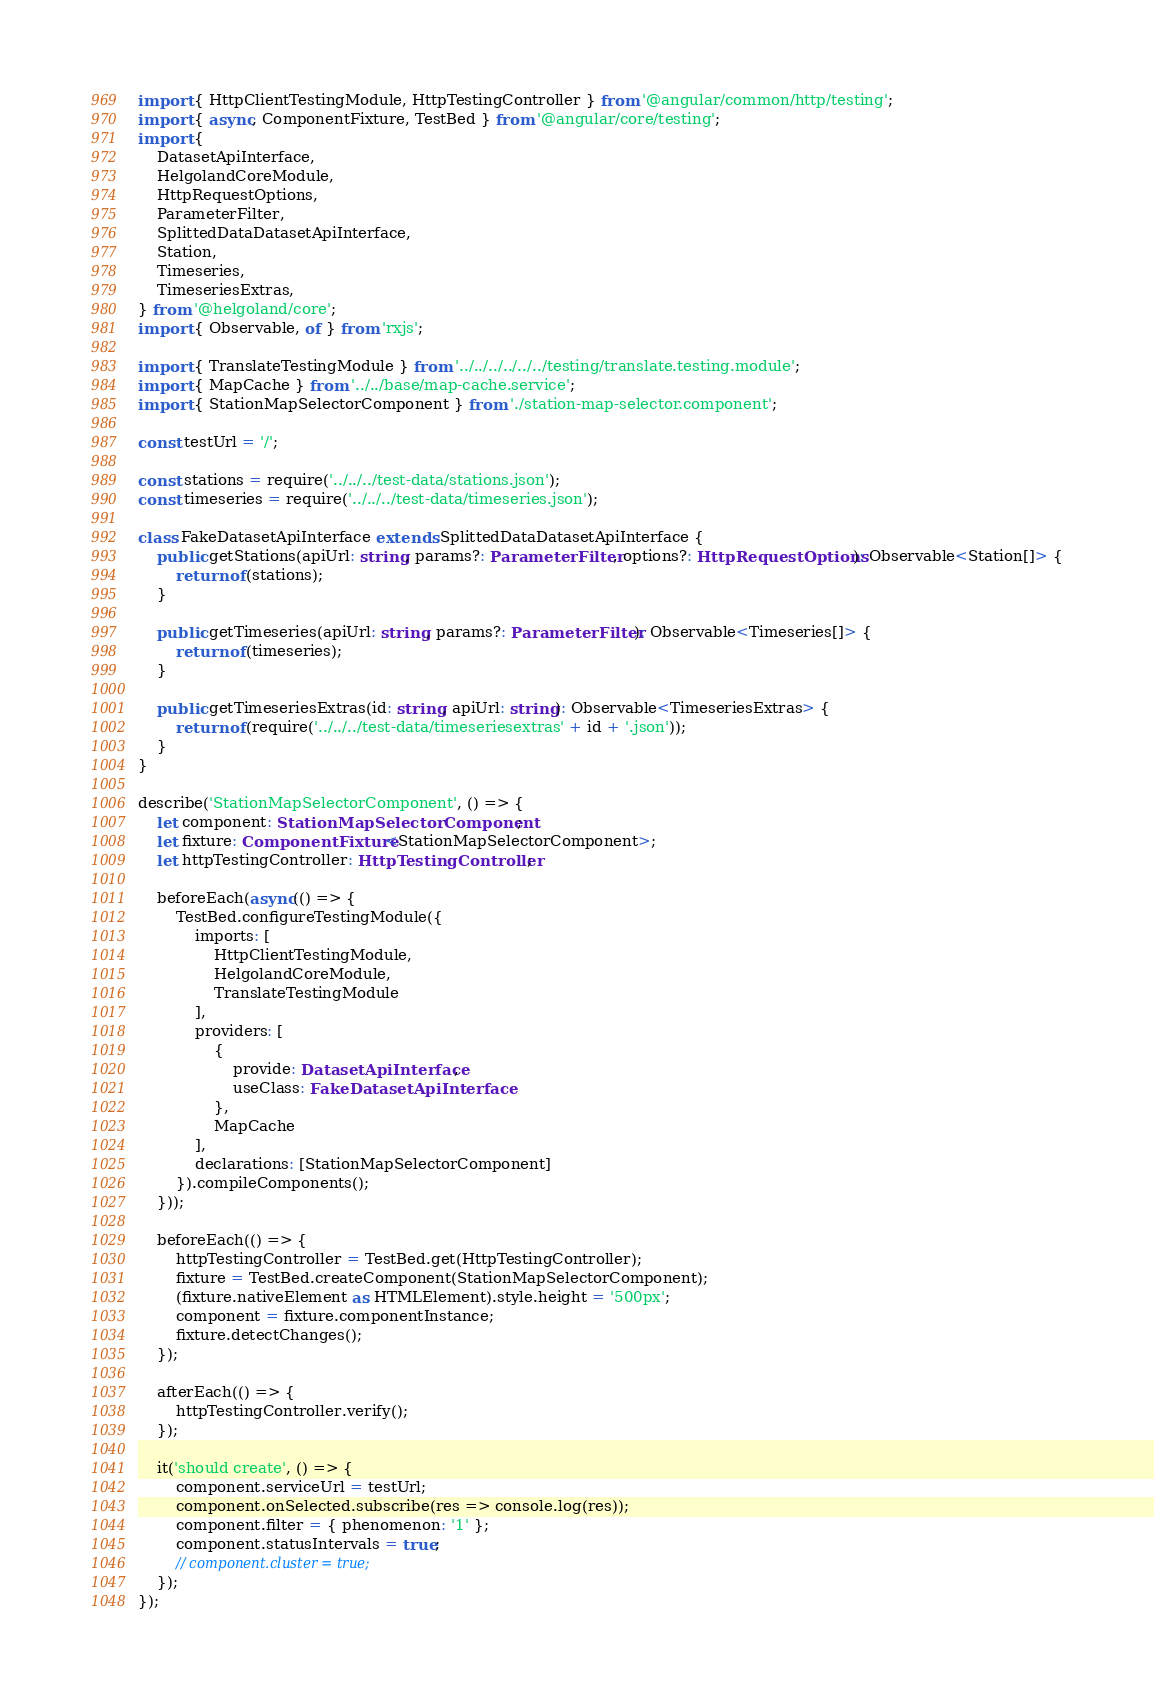<code> <loc_0><loc_0><loc_500><loc_500><_TypeScript_>import { HttpClientTestingModule, HttpTestingController } from '@angular/common/http/testing';
import { async, ComponentFixture, TestBed } from '@angular/core/testing';
import {
    DatasetApiInterface,
    HelgolandCoreModule,
    HttpRequestOptions,
    ParameterFilter,
    SplittedDataDatasetApiInterface,
    Station,
    Timeseries,
    TimeseriesExtras,
} from '@helgoland/core';
import { Observable, of } from 'rxjs';

import { TranslateTestingModule } from '../../../../../../testing/translate.testing.module';
import { MapCache } from '../../base/map-cache.service';
import { StationMapSelectorComponent } from './station-map-selector.component';

const testUrl = '/';

const stations = require('../../../test-data/stations.json');
const timeseries = require('../../../test-data/timeseries.json');

class FakeDatasetApiInterface extends SplittedDataDatasetApiInterface {
    public getStations(apiUrl: string, params?: ParameterFilter, options?: HttpRequestOptions): Observable<Station[]> {
        return of(stations);
    }

    public getTimeseries(apiUrl: string, params?: ParameterFilter): Observable<Timeseries[]> {
        return of(timeseries);
    }

    public getTimeseriesExtras(id: string, apiUrl: string): Observable<TimeseriesExtras> {
        return of(require('../../../test-data/timeseriesextras' + id + '.json'));
    }
}

describe('StationMapSelectorComponent', () => {
    let component: StationMapSelectorComponent;
    let fixture: ComponentFixture<StationMapSelectorComponent>;
    let httpTestingController: HttpTestingController;

    beforeEach(async(() => {
        TestBed.configureTestingModule({
            imports: [
                HttpClientTestingModule,
                HelgolandCoreModule,
                TranslateTestingModule
            ],
            providers: [
                {
                    provide: DatasetApiInterface,
                    useClass: FakeDatasetApiInterface
                },
                MapCache
            ],
            declarations: [StationMapSelectorComponent]
        }).compileComponents();
    }));

    beforeEach(() => {
        httpTestingController = TestBed.get(HttpTestingController);
        fixture = TestBed.createComponent(StationMapSelectorComponent);
        (fixture.nativeElement as HTMLElement).style.height = '500px';
        component = fixture.componentInstance;
        fixture.detectChanges();
    });

    afterEach(() => {
        httpTestingController.verify();
    });

    it('should create', () => {
        component.serviceUrl = testUrl;
        component.onSelected.subscribe(res => console.log(res));
        component.filter = { phenomenon: '1' };
        component.statusIntervals = true;
        // component.cluster = true;
    });
});
</code> 